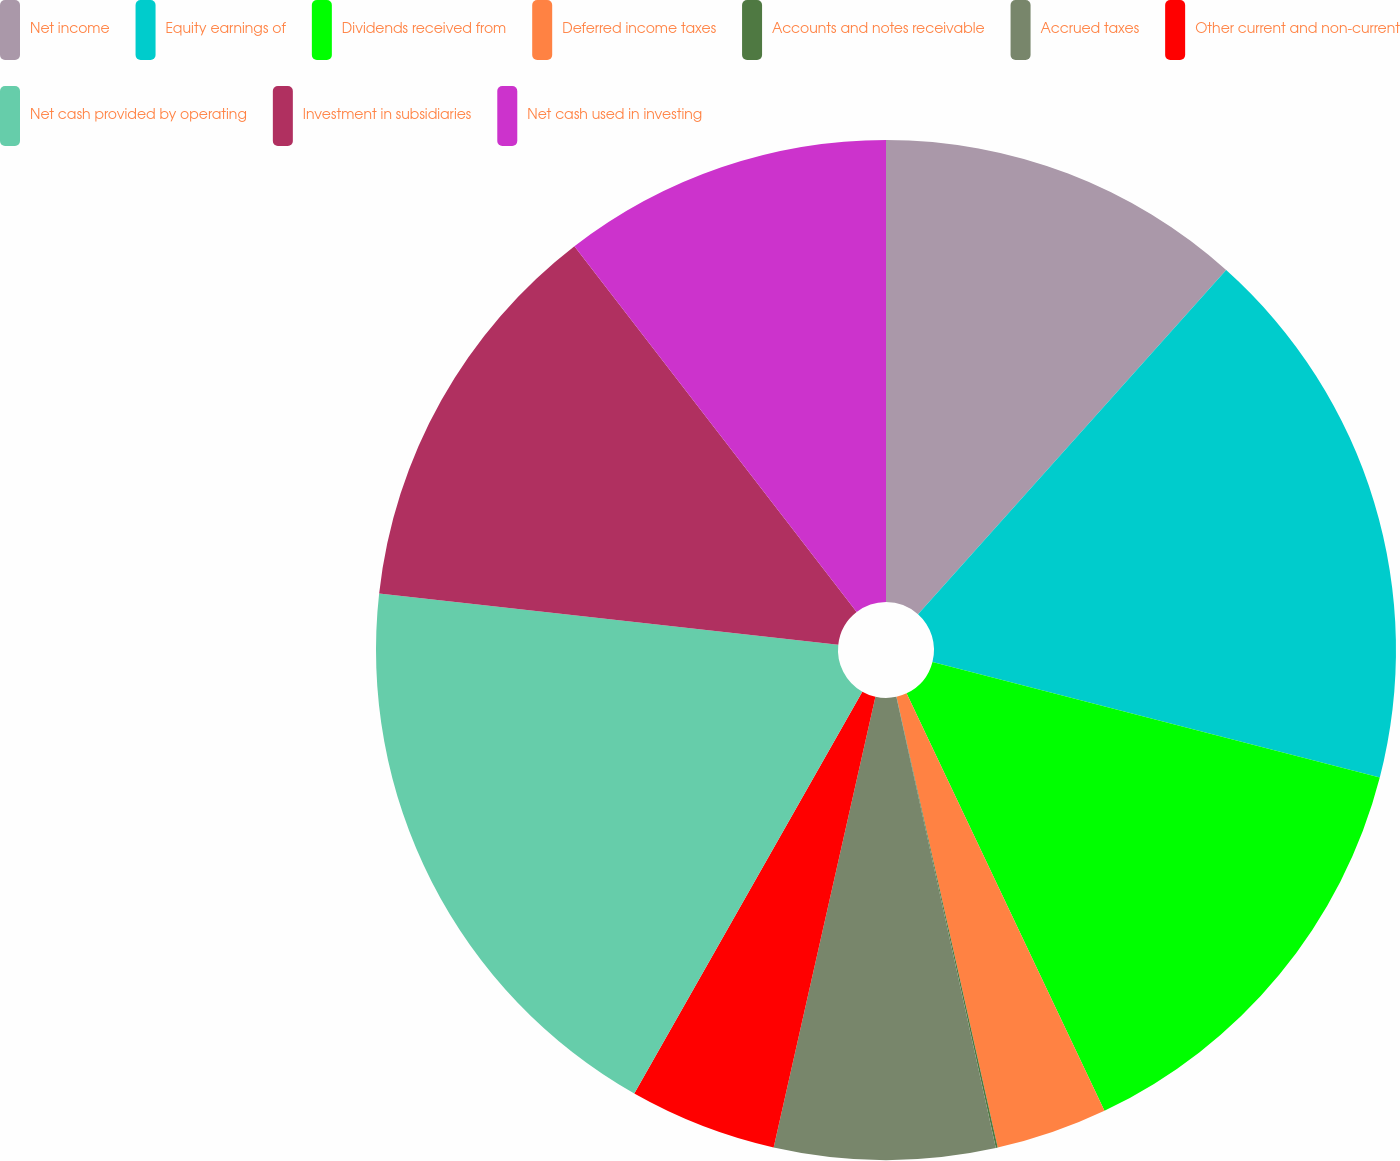Convert chart to OTSL. <chart><loc_0><loc_0><loc_500><loc_500><pie_chart><fcel>Net income<fcel>Equity earnings of<fcel>Dividends received from<fcel>Deferred income taxes<fcel>Accounts and notes receivable<fcel>Accrued taxes<fcel>Other current and non-current<fcel>Net cash provided by operating<fcel>Investment in subsidiaries<fcel>Net cash used in investing<nl><fcel>11.62%<fcel>17.4%<fcel>13.93%<fcel>3.53%<fcel>0.06%<fcel>6.99%<fcel>4.68%<fcel>18.55%<fcel>12.77%<fcel>10.46%<nl></chart> 